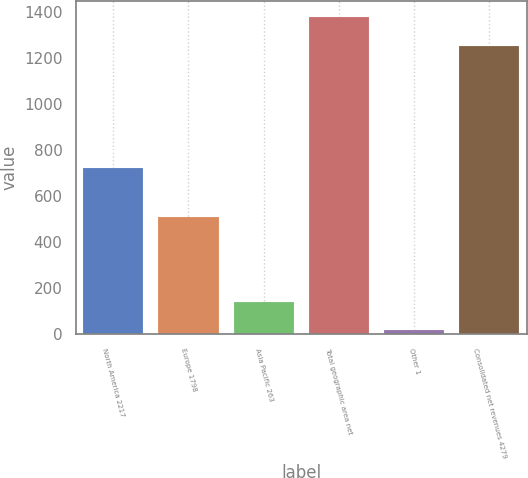<chart> <loc_0><loc_0><loc_500><loc_500><bar_chart><fcel>North America 2217<fcel>Europe 1798<fcel>Asia Pacific 263<fcel>Total geographic area net<fcel>Other 1<fcel>Consolidated net revenues 4279<nl><fcel>723<fcel>510<fcel>141.3<fcel>1378.3<fcel>16<fcel>1253<nl></chart> 